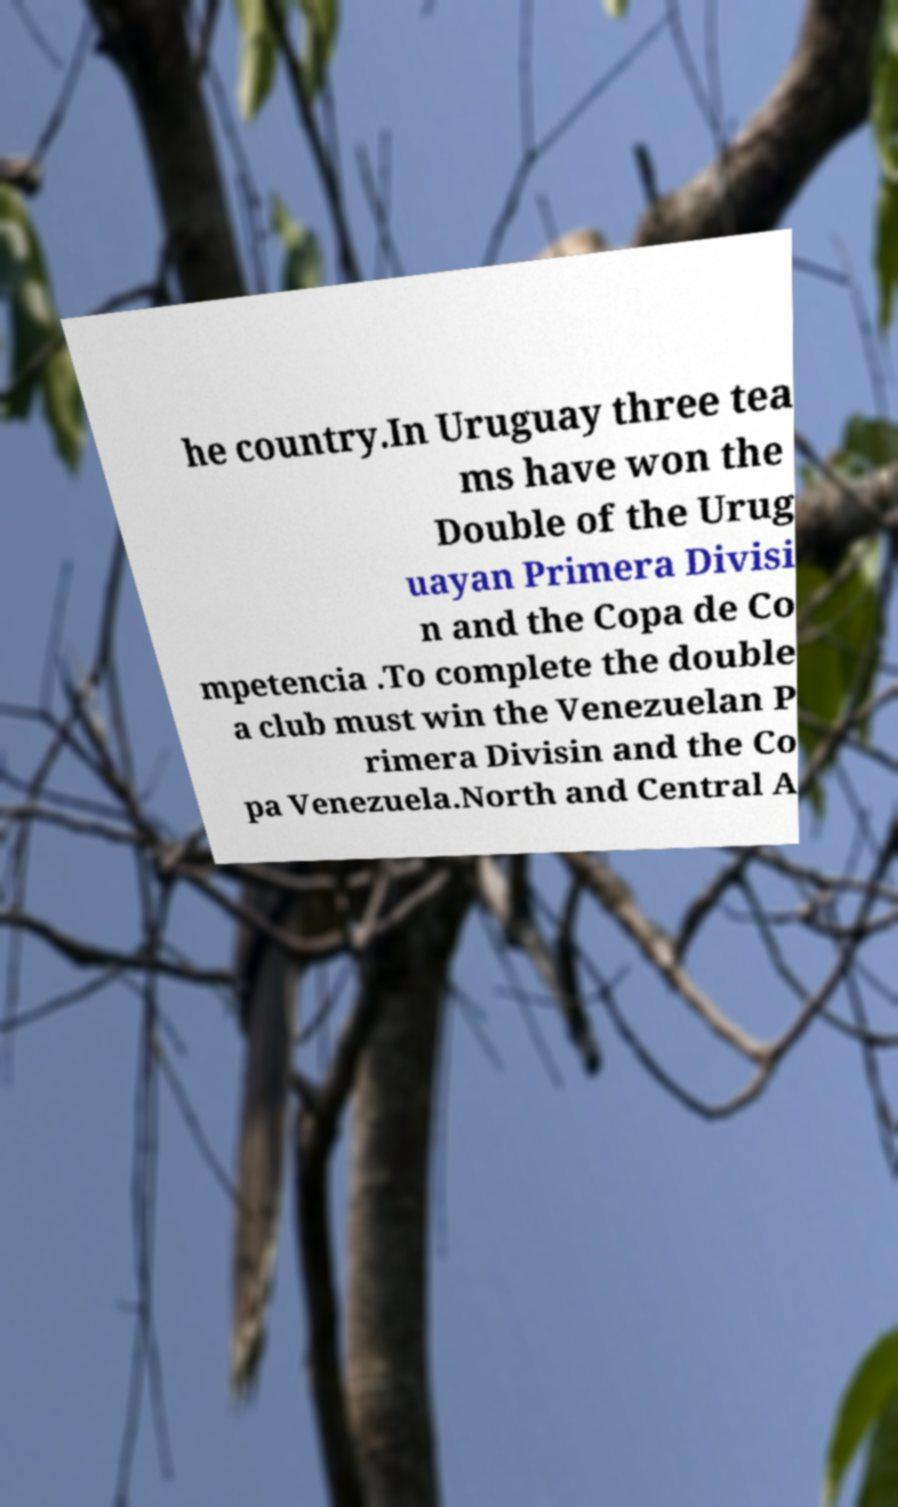There's text embedded in this image that I need extracted. Can you transcribe it verbatim? he country.In Uruguay three tea ms have won the Double of the Urug uayan Primera Divisi n and the Copa de Co mpetencia .To complete the double a club must win the Venezuelan P rimera Divisin and the Co pa Venezuela.North and Central A 